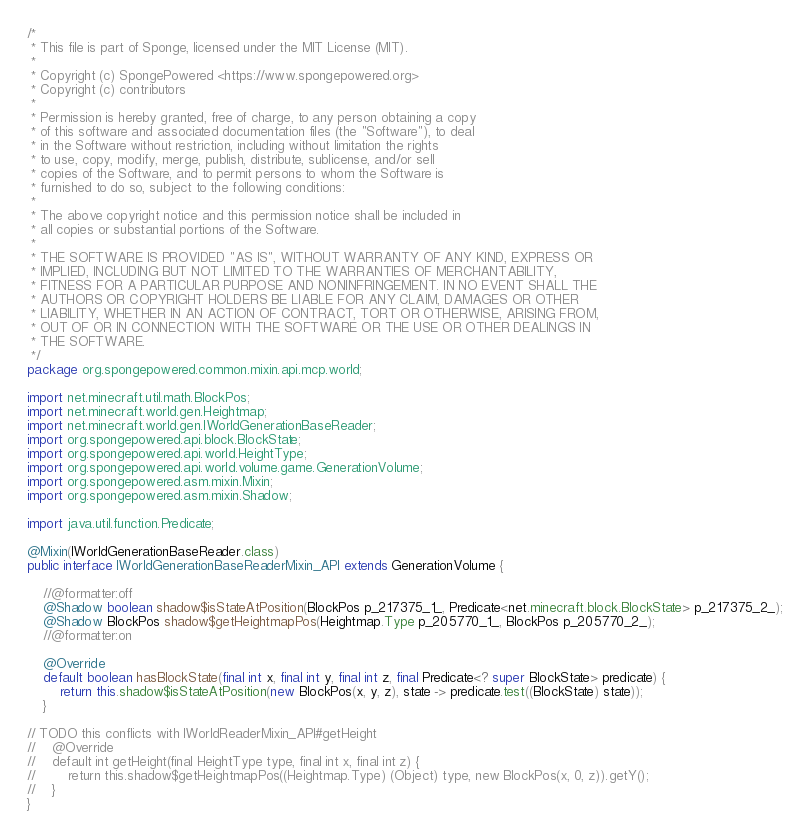<code> <loc_0><loc_0><loc_500><loc_500><_Java_>/*
 * This file is part of Sponge, licensed under the MIT License (MIT).
 *
 * Copyright (c) SpongePowered <https://www.spongepowered.org>
 * Copyright (c) contributors
 *
 * Permission is hereby granted, free of charge, to any person obtaining a copy
 * of this software and associated documentation files (the "Software"), to deal
 * in the Software without restriction, including without limitation the rights
 * to use, copy, modify, merge, publish, distribute, sublicense, and/or sell
 * copies of the Software, and to permit persons to whom the Software is
 * furnished to do so, subject to the following conditions:
 *
 * The above copyright notice and this permission notice shall be included in
 * all copies or substantial portions of the Software.
 *
 * THE SOFTWARE IS PROVIDED "AS IS", WITHOUT WARRANTY OF ANY KIND, EXPRESS OR
 * IMPLIED, INCLUDING BUT NOT LIMITED TO THE WARRANTIES OF MERCHANTABILITY,
 * FITNESS FOR A PARTICULAR PURPOSE AND NONINFRINGEMENT. IN NO EVENT SHALL THE
 * AUTHORS OR COPYRIGHT HOLDERS BE LIABLE FOR ANY CLAIM, DAMAGES OR OTHER
 * LIABILITY, WHETHER IN AN ACTION OF CONTRACT, TORT OR OTHERWISE, ARISING FROM,
 * OUT OF OR IN CONNECTION WITH THE SOFTWARE OR THE USE OR OTHER DEALINGS IN
 * THE SOFTWARE.
 */
package org.spongepowered.common.mixin.api.mcp.world;

import net.minecraft.util.math.BlockPos;
import net.minecraft.world.gen.Heightmap;
import net.minecraft.world.gen.IWorldGenerationBaseReader;
import org.spongepowered.api.block.BlockState;
import org.spongepowered.api.world.HeightType;
import org.spongepowered.api.world.volume.game.GenerationVolume;
import org.spongepowered.asm.mixin.Mixin;
import org.spongepowered.asm.mixin.Shadow;

import java.util.function.Predicate;

@Mixin(IWorldGenerationBaseReader.class)
public interface IWorldGenerationBaseReaderMixin_API extends GenerationVolume {

    //@formatter:off
    @Shadow boolean shadow$isStateAtPosition(BlockPos p_217375_1_, Predicate<net.minecraft.block.BlockState> p_217375_2_);
    @Shadow BlockPos shadow$getHeightmapPos(Heightmap.Type p_205770_1_, BlockPos p_205770_2_);
    //@formatter:on

    @Override
    default boolean hasBlockState(final int x, final int y, final int z, final Predicate<? super BlockState> predicate) {
        return this.shadow$isStateAtPosition(new BlockPos(x, y, z), state -> predicate.test((BlockState) state));
    }

// TODO this conflicts with IWorldReaderMixin_API#getHeight
//    @Override
//    default int getHeight(final HeightType type, final int x, final int z) {
//        return this.shadow$getHeightmapPos((Heightmap.Type) (Object) type, new BlockPos(x, 0, z)).getY();
//    }
}
</code> 